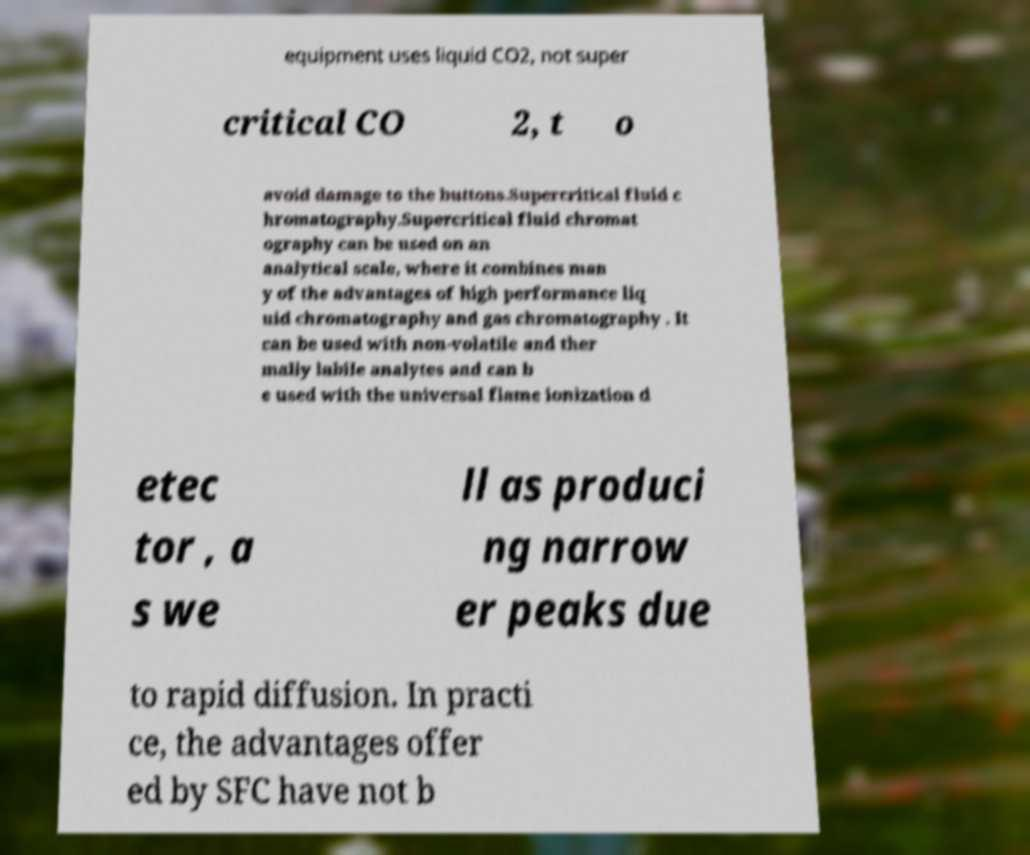There's text embedded in this image that I need extracted. Can you transcribe it verbatim? equipment uses liquid CO2, not super critical CO 2, t o avoid damage to the buttons.Supercritical fluid c hromatography.Supercritical fluid chromat ography can be used on an analytical scale, where it combines man y of the advantages of high performance liq uid chromatography and gas chromatography . It can be used with non-volatile and ther mally labile analytes and can b e used with the universal flame ionization d etec tor , a s we ll as produci ng narrow er peaks due to rapid diffusion. In practi ce, the advantages offer ed by SFC have not b 